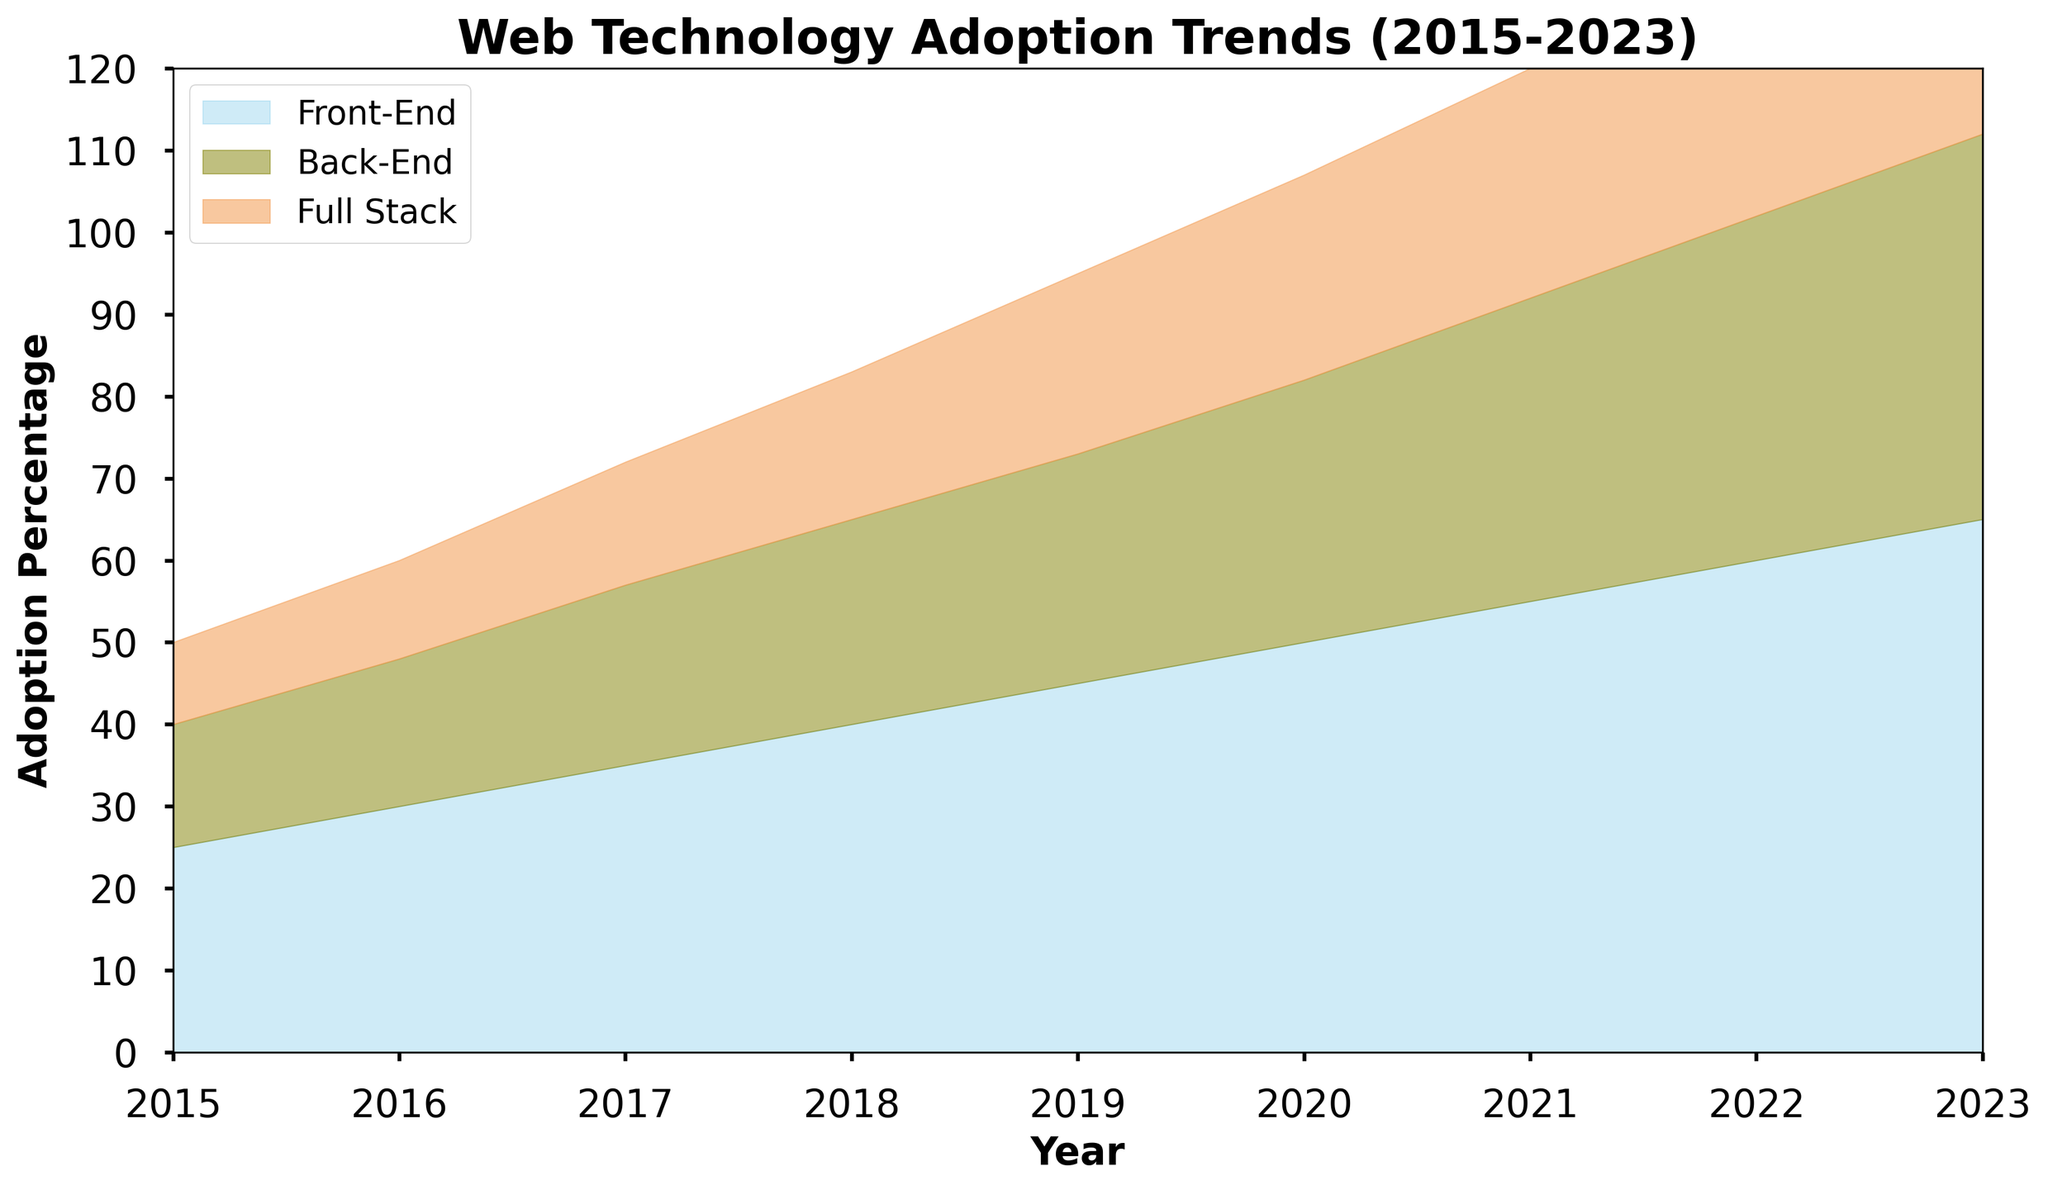What's the highest adoption percentage reached by Front-End technologies? The area chart shows the Front-End adoption in light blue. The highest point on the chart for Front-End adoption is at the year 2023, corresponding to an adoption percentage of 65%.
Answer: 65% Between which years did Back-End technologies see the most significant increase in adoption percentage? The area for Back-End technologies is colored olive. To determine the most significant increase, observe the years when the olive area grows the most. The biggest jump is between 2019 (28%) and 2020 (32%), which is an increase of 4%.
Answer: 2019 to 2020 What is the combined adoption percentage of Front-End and Full Stack technologies in 2018? To find the combined percentage, sum the Front-End and Full Stack adoption percentages for 2018. The chart shows 40% for Front-End and 18% for Full Stack. Adding these gives 40% + 18% = 58%.
Answer: 58% Which year did Full Stack technology adoption first exceed 20%? The Full Stack area is represented in sandy brown. First, locate where the adoption exceeds 20% on the Full Stack layer. This occurs in 2019, where the layer reaches 22%.
Answer: 2019 How does the adoption trend of Back-End technologies compare to the trend of Front-End technologies over the entire period? To answer this, observe the general slope and growth patterns of the olive area (Back-End) compared to the light blue area (Front-End). Front-End starts with a higher percentage and grows at a consistent faster rate than Back-End, which also grows steadily but remains consistently lower.
Answer: Front-End grows faster and consistently remains higher than Back-End Given the data, which technology stack shows the most consistent growth year-over-year? Consistency in growth can be gauged by looking at how steadily each area increases year over year. From the chart, the light blue (Front-End) area shows the most consistent, steady growth from 2015 to 2023 without major fluctuations.
Answer: Front-End In which year did the combined adoption percentage of all technologies first exceed 100%? To find this, sum the percentages of all three technologies for each year until the total exceeds 100%. By inspecting visually, it can be seen that the combined areas (light blue, olive, sandy brown) first exceed 100% in 2021.
Answer: 2021 Which technology saw the least adoption growth between 2015 and 2023? By observing the chart, the least overall increase is seen in the Full Stack layer (sandy brown), which starts at 10% in 2015 and goes up to 35% in 2023, a change of 25%.
Answer: Full Stack What percentage increase did Front-End technologies see from 2015 to 2020? Calculate the difference in Front-End adoption from 2015 (25%) to 2020 (50%). The increase is 50% - 25% = 25%.
Answer: 25% 